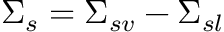Convert formula to latex. <formula><loc_0><loc_0><loc_500><loc_500>\Sigma _ { s } = \Sigma _ { s v } - \Sigma _ { s l }</formula> 